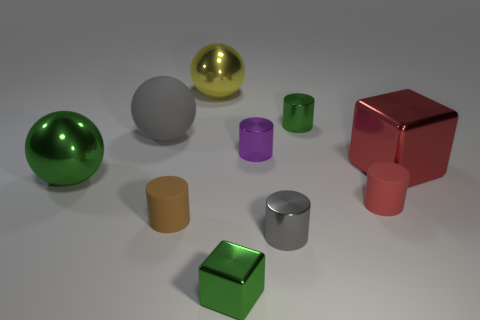Subtract all small green cylinders. How many cylinders are left? 4 Subtract 1 cylinders. How many cylinders are left? 4 Subtract all red cylinders. How many cylinders are left? 4 Subtract all blue cylinders. Subtract all cyan balls. How many cylinders are left? 5 Subtract all cubes. How many objects are left? 8 Subtract 1 green cylinders. How many objects are left? 9 Subtract all cyan things. Subtract all tiny purple objects. How many objects are left? 9 Add 7 big rubber spheres. How many big rubber spheres are left? 8 Add 1 tiny purple metallic cylinders. How many tiny purple metallic cylinders exist? 2 